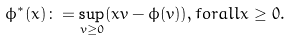<formula> <loc_0><loc_0><loc_500><loc_500>\phi ^ { * } ( x ) \colon = \sup _ { v \geq 0 } ( x v - \phi ( v ) ) , f o r a l l x \geq 0 .</formula> 